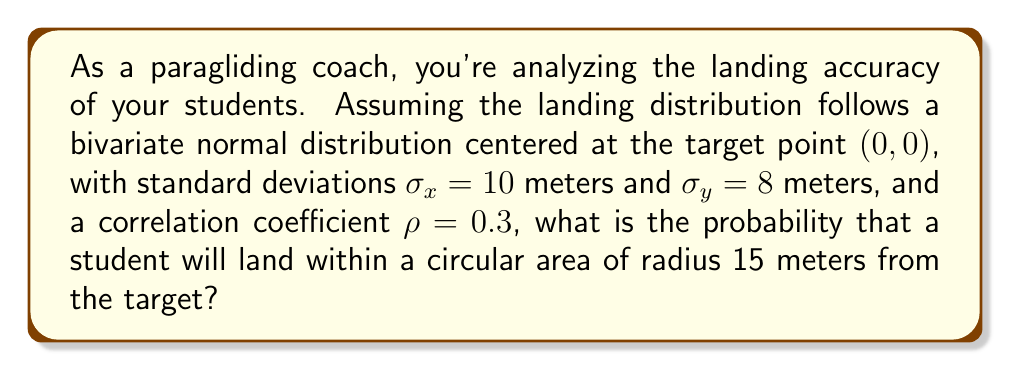Help me with this question. To solve this problem, we'll follow these steps:

1) The probability density function (PDF) of a bivariate normal distribution is given by:

   $$f(x,y) = \frac{1}{2\pi\sigma_x\sigma_y\sqrt{1-\rho^2}} \exp\left(-\frac{1}{2(1-\rho^2)}\left[\frac{x^2}{\sigma_x^2} + \frac{y^2}{\sigma_y^2} - \frac{2\rho xy}{\sigma_x\sigma_y}\right]\right)$$

2) To find the probability of landing within a circular area, we need to integrate this function over the circle. However, this is mathematically complex, so we'll use a transformation.

3) We can transform the problem into standard bivariate normal form using the following substitutions:

   $$X = \frac{x}{\sigma_x}, Y = \frac{y}{\sigma_y}$$

4) The circular region in the original coordinates becomes an elliptical region in the transformed coordinates:

   $$\frac{x^2}{10^2} + \frac{y^2}{8^2} \leq 15^2$$

5) This ellipse has semi-major axis $a = 15$ and semi-minor axis $b = 12$.

6) The probability of landing within this ellipse is approximately equal to:

   $$P = 1 - e^{-\frac{a^2 + b^2}{2}}$$

7) Substituting the values:

   $$P = 1 - e^{-\frac{15^2 + 12^2}{2}} = 1 - e^{-\frac{369}{2}}$$

8) Calculating this value:

   $$P \approx 0.8397$$

Therefore, the probability of landing within 15 meters of the target is approximately 0.8397 or 83.97%.
Answer: The probability that a student will land within a circular area of radius 15 meters from the target is approximately 0.8397 or 83.97%. 